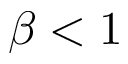<formula> <loc_0><loc_0><loc_500><loc_500>\beta < 1</formula> 